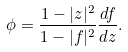Convert formula to latex. <formula><loc_0><loc_0><loc_500><loc_500>\phi = \frac { 1 - | z | ^ { 2 } } { 1 - | f | ^ { 2 } } \frac { d f } { d z } .</formula> 